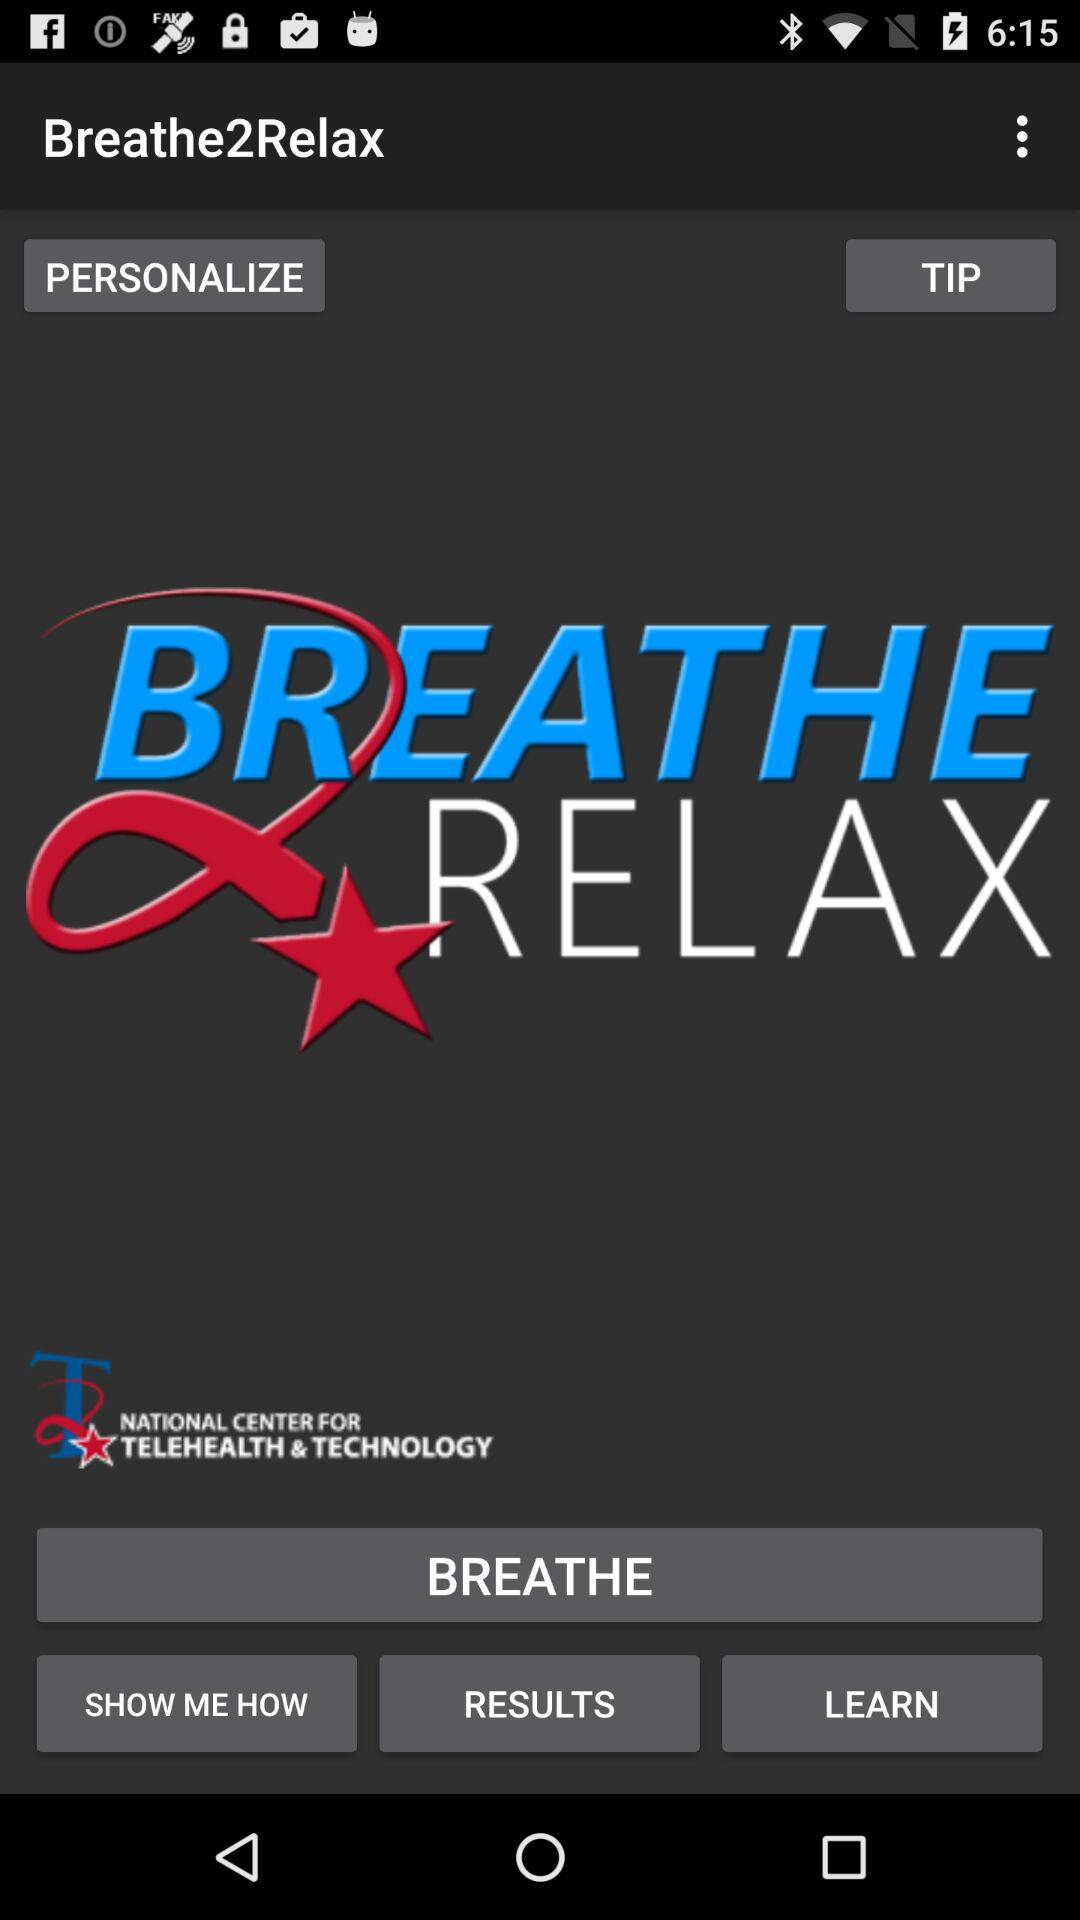What is the name of the application? The name of the application is "Breathe2Relax". 